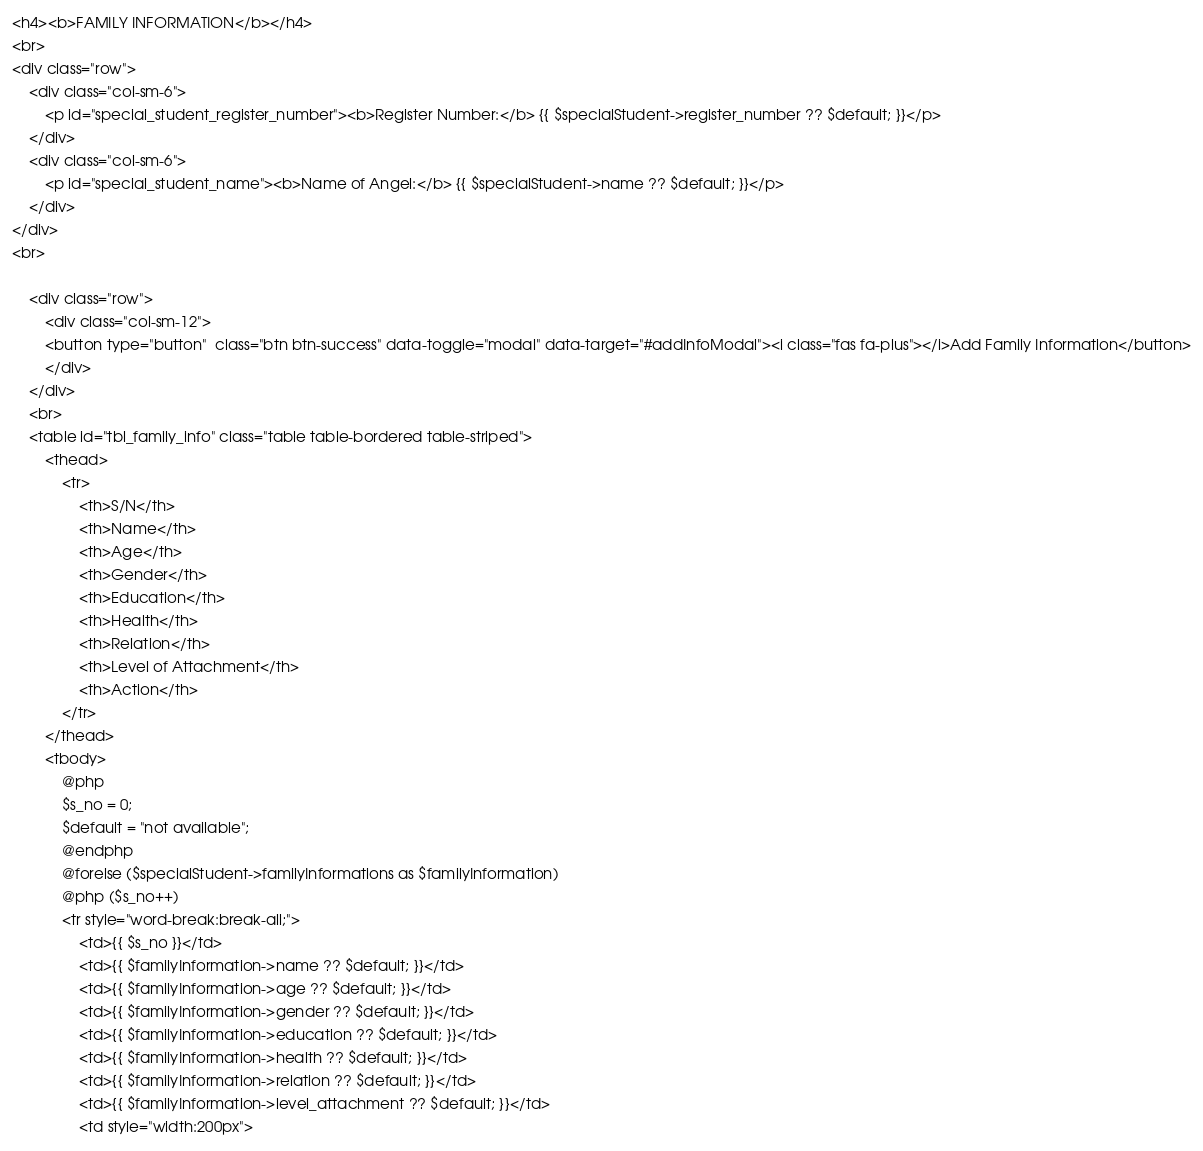Convert code to text. <code><loc_0><loc_0><loc_500><loc_500><_PHP_><h4><b>FAMILY INFORMATION</b></h4>
<br>
<div class="row">
    <div class="col-sm-6">
        <p id="special_student_register_number"><b>Register Number:</b> {{ $specialStudent->register_number ?? $default; }}</p>
    </div>
    <div class="col-sm-6">
        <p id="special_student_name"><b>Name of Angel:</b> {{ $specialStudent->name ?? $default; }}</p>
    </div>
</div>
<br>

    <div class="row">
        <div class="col-sm-12">
        <button type="button"  class="btn btn-success" data-toggle="modal" data-target="#addInfoModal"><i class="fas fa-plus"></i>Add Family Information</button>
        </div>
    </div>
    <br>
    <table id="tbl_family_info" class="table table-bordered table-striped">
        <thead>
            <tr>
                <th>S/N</th>
                <th>Name</th>
                <th>Age</th>
                <th>Gender</th>
                <th>Education</th>
                <th>Health</th>
                <th>Relation</th>
                <th>Level of Attachment</th>
                <th>Action</th>
            </tr>
        </thead>
        <tbody>
            @php
            $s_no = 0;
            $default = "not available";
            @endphp
            @forelse ($specialStudent->familyInformations as $familyInformation) 
            @php ($s_no++)
            <tr style="word-break:break-all;">
                <td>{{ $s_no }}</td>
                <td>{{ $familyInformation->name ?? $default; }}</td>
                <td>{{ $familyInformation->age ?? $default; }}</td> 
                <td>{{ $familyInformation->gender ?? $default; }}</td>
                <td>{{ $familyInformation->education ?? $default; }}</td>
                <td>{{ $familyInformation->health ?? $default; }}</td> 
                <td>{{ $familyInformation->relation ?? $default; }}</td>
                <td>{{ $familyInformation->level_attachment ?? $default; }}</td>                   
                <td style="width:200px"></code> 